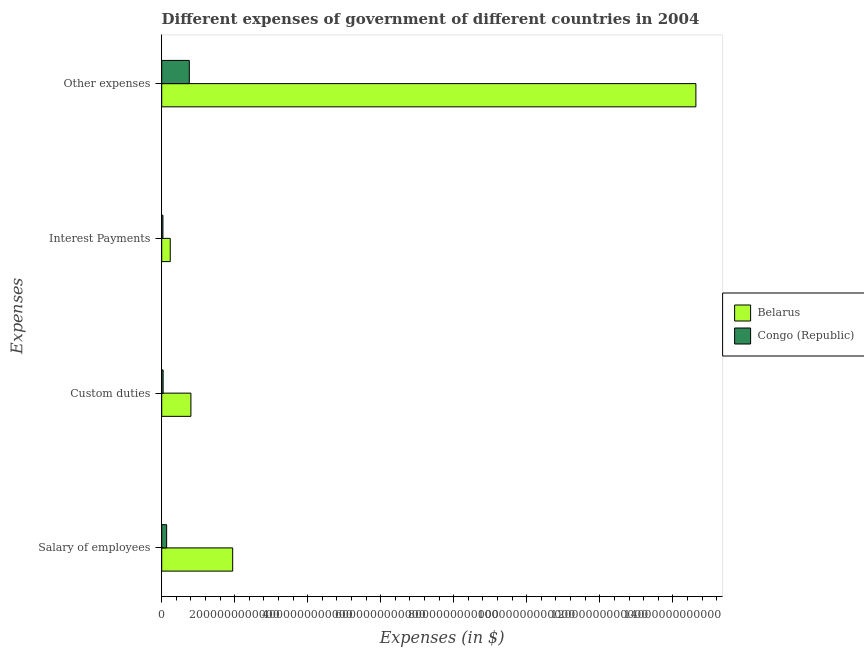How many groups of bars are there?
Your response must be concise. 4. Are the number of bars on each tick of the Y-axis equal?
Keep it short and to the point. Yes. How many bars are there on the 1st tick from the bottom?
Offer a very short reply. 2. What is the label of the 2nd group of bars from the top?
Your answer should be very brief. Interest Payments. What is the amount spent on custom duties in Congo (Republic)?
Provide a succinct answer. 3.88e+1. Across all countries, what is the maximum amount spent on interest payments?
Ensure brevity in your answer.  2.34e+11. Across all countries, what is the minimum amount spent on other expenses?
Give a very brief answer. 7.56e+11. In which country was the amount spent on custom duties maximum?
Provide a succinct answer. Belarus. In which country was the amount spent on other expenses minimum?
Make the answer very short. Congo (Republic). What is the total amount spent on interest payments in the graph?
Ensure brevity in your answer.  2.68e+11. What is the difference between the amount spent on other expenses in Belarus and that in Congo (Republic)?
Offer a terse response. 1.39e+13. What is the difference between the amount spent on custom duties in Congo (Republic) and the amount spent on salary of employees in Belarus?
Provide a short and direct response. -1.91e+12. What is the average amount spent on salary of employees per country?
Give a very brief answer. 1.04e+12. What is the difference between the amount spent on custom duties and amount spent on salary of employees in Congo (Republic)?
Make the answer very short. -9.60e+1. In how many countries, is the amount spent on custom duties greater than 14800000000000 $?
Provide a short and direct response. 0. What is the ratio of the amount spent on interest payments in Congo (Republic) to that in Belarus?
Give a very brief answer. 0.14. Is the amount spent on salary of employees in Congo (Republic) less than that in Belarus?
Offer a very short reply. Yes. Is the difference between the amount spent on salary of employees in Belarus and Congo (Republic) greater than the difference between the amount spent on interest payments in Belarus and Congo (Republic)?
Make the answer very short. Yes. What is the difference between the highest and the second highest amount spent on interest payments?
Keep it short and to the point. 2.00e+11. What is the difference between the highest and the lowest amount spent on other expenses?
Make the answer very short. 1.39e+13. In how many countries, is the amount spent on other expenses greater than the average amount spent on other expenses taken over all countries?
Your answer should be very brief. 1. Is it the case that in every country, the sum of the amount spent on salary of employees and amount spent on other expenses is greater than the sum of amount spent on custom duties and amount spent on interest payments?
Your answer should be very brief. Yes. What does the 1st bar from the top in Custom duties represents?
Give a very brief answer. Congo (Republic). What does the 1st bar from the bottom in Other expenses represents?
Make the answer very short. Belarus. Is it the case that in every country, the sum of the amount spent on salary of employees and amount spent on custom duties is greater than the amount spent on interest payments?
Offer a terse response. Yes. How many bars are there?
Give a very brief answer. 8. Are all the bars in the graph horizontal?
Your response must be concise. Yes. How many countries are there in the graph?
Ensure brevity in your answer.  2. What is the difference between two consecutive major ticks on the X-axis?
Make the answer very short. 2.00e+12. Does the graph contain any zero values?
Your response must be concise. No. What is the title of the graph?
Provide a succinct answer. Different expenses of government of different countries in 2004. Does "Puerto Rico" appear as one of the legend labels in the graph?
Your response must be concise. No. What is the label or title of the X-axis?
Your answer should be compact. Expenses (in $). What is the label or title of the Y-axis?
Your answer should be very brief. Expenses. What is the Expenses (in $) in Belarus in Salary of employees?
Ensure brevity in your answer.  1.94e+12. What is the Expenses (in $) of Congo (Republic) in Salary of employees?
Keep it short and to the point. 1.35e+11. What is the Expenses (in $) of Belarus in Custom duties?
Keep it short and to the point. 8.00e+11. What is the Expenses (in $) in Congo (Republic) in Custom duties?
Your answer should be very brief. 3.88e+1. What is the Expenses (in $) of Belarus in Interest Payments?
Make the answer very short. 2.34e+11. What is the Expenses (in $) in Congo (Republic) in Interest Payments?
Offer a very short reply. 3.37e+1. What is the Expenses (in $) of Belarus in Other expenses?
Keep it short and to the point. 1.46e+13. What is the Expenses (in $) in Congo (Republic) in Other expenses?
Offer a very short reply. 7.56e+11. Across all Expenses, what is the maximum Expenses (in $) in Belarus?
Your response must be concise. 1.46e+13. Across all Expenses, what is the maximum Expenses (in $) of Congo (Republic)?
Keep it short and to the point. 7.56e+11. Across all Expenses, what is the minimum Expenses (in $) in Belarus?
Your answer should be very brief. 2.34e+11. Across all Expenses, what is the minimum Expenses (in $) in Congo (Republic)?
Provide a short and direct response. 3.37e+1. What is the total Expenses (in $) in Belarus in the graph?
Provide a short and direct response. 1.76e+13. What is the total Expenses (in $) of Congo (Republic) in the graph?
Your answer should be compact. 9.64e+11. What is the difference between the Expenses (in $) in Belarus in Salary of employees and that in Custom duties?
Your response must be concise. 1.14e+12. What is the difference between the Expenses (in $) of Congo (Republic) in Salary of employees and that in Custom duties?
Make the answer very short. 9.60e+1. What is the difference between the Expenses (in $) of Belarus in Salary of employees and that in Interest Payments?
Provide a short and direct response. 1.71e+12. What is the difference between the Expenses (in $) of Congo (Republic) in Salary of employees and that in Interest Payments?
Your response must be concise. 1.01e+11. What is the difference between the Expenses (in $) in Belarus in Salary of employees and that in Other expenses?
Make the answer very short. -1.27e+13. What is the difference between the Expenses (in $) in Congo (Republic) in Salary of employees and that in Other expenses?
Offer a terse response. -6.21e+11. What is the difference between the Expenses (in $) of Belarus in Custom duties and that in Interest Payments?
Keep it short and to the point. 5.66e+11. What is the difference between the Expenses (in $) of Congo (Republic) in Custom duties and that in Interest Payments?
Your response must be concise. 5.10e+09. What is the difference between the Expenses (in $) in Belarus in Custom duties and that in Other expenses?
Provide a succinct answer. -1.38e+13. What is the difference between the Expenses (in $) in Congo (Republic) in Custom duties and that in Other expenses?
Provide a succinct answer. -7.17e+11. What is the difference between the Expenses (in $) in Belarus in Interest Payments and that in Other expenses?
Give a very brief answer. -1.44e+13. What is the difference between the Expenses (in $) of Congo (Republic) in Interest Payments and that in Other expenses?
Your answer should be compact. -7.23e+11. What is the difference between the Expenses (in $) of Belarus in Salary of employees and the Expenses (in $) of Congo (Republic) in Custom duties?
Offer a terse response. 1.91e+12. What is the difference between the Expenses (in $) of Belarus in Salary of employees and the Expenses (in $) of Congo (Republic) in Interest Payments?
Make the answer very short. 1.91e+12. What is the difference between the Expenses (in $) of Belarus in Salary of employees and the Expenses (in $) of Congo (Republic) in Other expenses?
Provide a succinct answer. 1.19e+12. What is the difference between the Expenses (in $) in Belarus in Custom duties and the Expenses (in $) in Congo (Republic) in Interest Payments?
Provide a succinct answer. 7.66e+11. What is the difference between the Expenses (in $) of Belarus in Custom duties and the Expenses (in $) of Congo (Republic) in Other expenses?
Offer a very short reply. 4.33e+1. What is the difference between the Expenses (in $) of Belarus in Interest Payments and the Expenses (in $) of Congo (Republic) in Other expenses?
Your response must be concise. -5.22e+11. What is the average Expenses (in $) in Belarus per Expenses?
Your response must be concise. 4.40e+12. What is the average Expenses (in $) of Congo (Republic) per Expenses?
Provide a short and direct response. 2.41e+11. What is the difference between the Expenses (in $) in Belarus and Expenses (in $) in Congo (Republic) in Salary of employees?
Your response must be concise. 1.81e+12. What is the difference between the Expenses (in $) in Belarus and Expenses (in $) in Congo (Republic) in Custom duties?
Give a very brief answer. 7.61e+11. What is the difference between the Expenses (in $) in Belarus and Expenses (in $) in Congo (Republic) in Interest Payments?
Your response must be concise. 2.00e+11. What is the difference between the Expenses (in $) of Belarus and Expenses (in $) of Congo (Republic) in Other expenses?
Give a very brief answer. 1.39e+13. What is the ratio of the Expenses (in $) in Belarus in Salary of employees to that in Custom duties?
Ensure brevity in your answer.  2.43. What is the ratio of the Expenses (in $) of Congo (Republic) in Salary of employees to that in Custom duties?
Your response must be concise. 3.47. What is the ratio of the Expenses (in $) in Belarus in Salary of employees to that in Interest Payments?
Provide a short and direct response. 8.31. What is the ratio of the Expenses (in $) in Congo (Republic) in Salary of employees to that in Interest Payments?
Make the answer very short. 4. What is the ratio of the Expenses (in $) in Belarus in Salary of employees to that in Other expenses?
Provide a short and direct response. 0.13. What is the ratio of the Expenses (in $) in Congo (Republic) in Salary of employees to that in Other expenses?
Ensure brevity in your answer.  0.18. What is the ratio of the Expenses (in $) in Belarus in Custom duties to that in Interest Payments?
Provide a short and direct response. 3.42. What is the ratio of the Expenses (in $) of Congo (Republic) in Custom duties to that in Interest Payments?
Provide a short and direct response. 1.15. What is the ratio of the Expenses (in $) in Belarus in Custom duties to that in Other expenses?
Your answer should be very brief. 0.05. What is the ratio of the Expenses (in $) in Congo (Republic) in Custom duties to that in Other expenses?
Offer a very short reply. 0.05. What is the ratio of the Expenses (in $) in Belarus in Interest Payments to that in Other expenses?
Offer a terse response. 0.02. What is the ratio of the Expenses (in $) in Congo (Republic) in Interest Payments to that in Other expenses?
Give a very brief answer. 0.04. What is the difference between the highest and the second highest Expenses (in $) of Belarus?
Give a very brief answer. 1.27e+13. What is the difference between the highest and the second highest Expenses (in $) of Congo (Republic)?
Keep it short and to the point. 6.21e+11. What is the difference between the highest and the lowest Expenses (in $) of Belarus?
Make the answer very short. 1.44e+13. What is the difference between the highest and the lowest Expenses (in $) in Congo (Republic)?
Offer a terse response. 7.23e+11. 